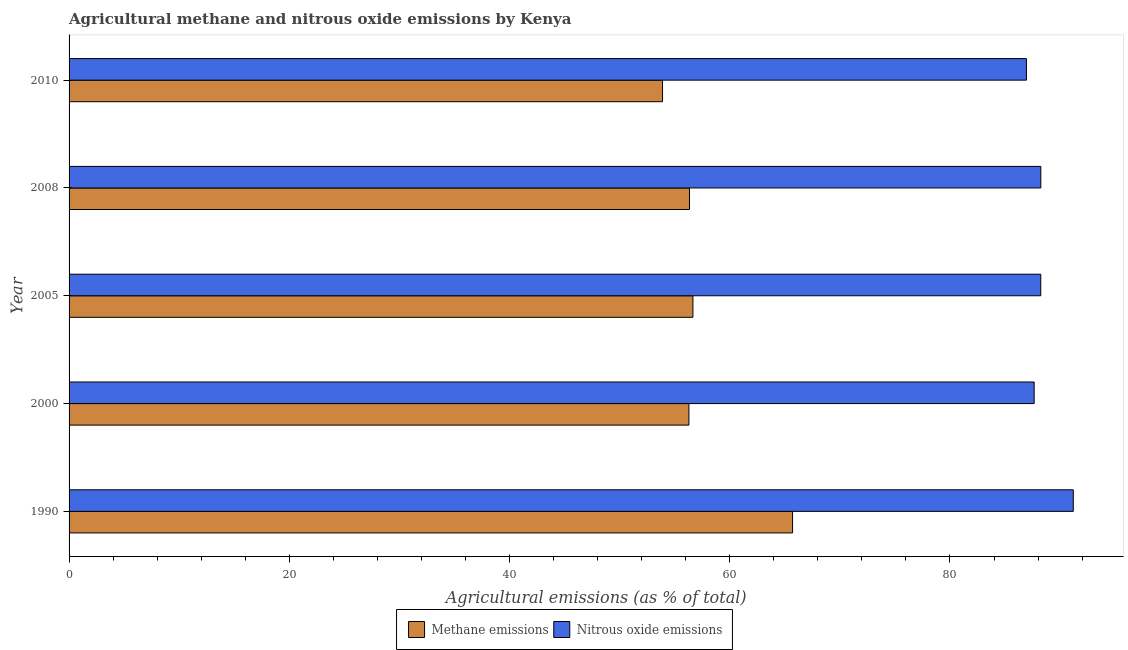How many different coloured bars are there?
Provide a succinct answer. 2. How many groups of bars are there?
Offer a terse response. 5. Are the number of bars on each tick of the Y-axis equal?
Offer a terse response. Yes. How many bars are there on the 5th tick from the bottom?
Your answer should be very brief. 2. What is the amount of nitrous oxide emissions in 2005?
Ensure brevity in your answer.  88.25. Across all years, what is the maximum amount of methane emissions?
Your answer should be compact. 65.71. Across all years, what is the minimum amount of methane emissions?
Your response must be concise. 53.9. In which year was the amount of nitrous oxide emissions maximum?
Ensure brevity in your answer.  1990. In which year was the amount of methane emissions minimum?
Your response must be concise. 2010. What is the total amount of nitrous oxide emissions in the graph?
Your answer should be compact. 442.29. What is the difference between the amount of nitrous oxide emissions in 1990 and that in 2005?
Your answer should be very brief. 2.95. What is the difference between the amount of methane emissions in 2005 and the amount of nitrous oxide emissions in 2010?
Offer a terse response. -30.29. What is the average amount of methane emissions per year?
Your response must be concise. 57.78. In the year 2008, what is the difference between the amount of methane emissions and amount of nitrous oxide emissions?
Offer a terse response. -31.91. In how many years, is the amount of methane emissions greater than 40 %?
Your answer should be very brief. 5. What is the ratio of the amount of nitrous oxide emissions in 1990 to that in 2000?
Give a very brief answer. 1.04. Is the difference between the amount of nitrous oxide emissions in 2000 and 2010 greater than the difference between the amount of methane emissions in 2000 and 2010?
Your answer should be compact. No. What is the difference between the highest and the second highest amount of methane emissions?
Provide a short and direct response. 9.05. What is the difference between the highest and the lowest amount of methane emissions?
Provide a succinct answer. 11.81. What does the 2nd bar from the top in 1990 represents?
Your answer should be compact. Methane emissions. What does the 1st bar from the bottom in 2005 represents?
Keep it short and to the point. Methane emissions. Are all the bars in the graph horizontal?
Keep it short and to the point. Yes. How many years are there in the graph?
Your response must be concise. 5. Does the graph contain any zero values?
Provide a short and direct response. No. Does the graph contain grids?
Keep it short and to the point. No. Where does the legend appear in the graph?
Offer a very short reply. Bottom center. How many legend labels are there?
Offer a terse response. 2. What is the title of the graph?
Your answer should be very brief. Agricultural methane and nitrous oxide emissions by Kenya. What is the label or title of the X-axis?
Your answer should be very brief. Agricultural emissions (as % of total). What is the Agricultural emissions (as % of total) of Methane emissions in 1990?
Give a very brief answer. 65.71. What is the Agricultural emissions (as % of total) of Nitrous oxide emissions in 1990?
Make the answer very short. 91.2. What is the Agricultural emissions (as % of total) of Methane emissions in 2000?
Offer a very short reply. 56.29. What is the Agricultural emissions (as % of total) in Nitrous oxide emissions in 2000?
Your answer should be compact. 87.65. What is the Agricultural emissions (as % of total) in Methane emissions in 2005?
Provide a short and direct response. 56.66. What is the Agricultural emissions (as % of total) in Nitrous oxide emissions in 2005?
Offer a terse response. 88.25. What is the Agricultural emissions (as % of total) of Methane emissions in 2008?
Offer a terse response. 56.35. What is the Agricultural emissions (as % of total) of Nitrous oxide emissions in 2008?
Offer a terse response. 88.25. What is the Agricultural emissions (as % of total) of Methane emissions in 2010?
Make the answer very short. 53.9. What is the Agricultural emissions (as % of total) in Nitrous oxide emissions in 2010?
Ensure brevity in your answer.  86.94. Across all years, what is the maximum Agricultural emissions (as % of total) of Methane emissions?
Keep it short and to the point. 65.71. Across all years, what is the maximum Agricultural emissions (as % of total) in Nitrous oxide emissions?
Keep it short and to the point. 91.2. Across all years, what is the minimum Agricultural emissions (as % of total) of Methane emissions?
Offer a very short reply. 53.9. Across all years, what is the minimum Agricultural emissions (as % of total) in Nitrous oxide emissions?
Give a very brief answer. 86.94. What is the total Agricultural emissions (as % of total) in Methane emissions in the graph?
Ensure brevity in your answer.  288.9. What is the total Agricultural emissions (as % of total) in Nitrous oxide emissions in the graph?
Make the answer very short. 442.29. What is the difference between the Agricultural emissions (as % of total) of Methane emissions in 1990 and that in 2000?
Provide a succinct answer. 9.42. What is the difference between the Agricultural emissions (as % of total) in Nitrous oxide emissions in 1990 and that in 2000?
Give a very brief answer. 3.55. What is the difference between the Agricultural emissions (as % of total) in Methane emissions in 1990 and that in 2005?
Your answer should be compact. 9.05. What is the difference between the Agricultural emissions (as % of total) of Nitrous oxide emissions in 1990 and that in 2005?
Offer a very short reply. 2.95. What is the difference between the Agricultural emissions (as % of total) of Methane emissions in 1990 and that in 2008?
Offer a very short reply. 9.36. What is the difference between the Agricultural emissions (as % of total) in Nitrous oxide emissions in 1990 and that in 2008?
Your response must be concise. 2.95. What is the difference between the Agricultural emissions (as % of total) of Methane emissions in 1990 and that in 2010?
Your answer should be very brief. 11.81. What is the difference between the Agricultural emissions (as % of total) in Nitrous oxide emissions in 1990 and that in 2010?
Provide a short and direct response. 4.26. What is the difference between the Agricultural emissions (as % of total) in Methane emissions in 2000 and that in 2005?
Your response must be concise. -0.37. What is the difference between the Agricultural emissions (as % of total) in Nitrous oxide emissions in 2000 and that in 2005?
Offer a terse response. -0.6. What is the difference between the Agricultural emissions (as % of total) in Methane emissions in 2000 and that in 2008?
Your answer should be very brief. -0.06. What is the difference between the Agricultural emissions (as % of total) of Nitrous oxide emissions in 2000 and that in 2008?
Your response must be concise. -0.61. What is the difference between the Agricultural emissions (as % of total) of Methane emissions in 2000 and that in 2010?
Your answer should be very brief. 2.39. What is the difference between the Agricultural emissions (as % of total) in Nitrous oxide emissions in 2000 and that in 2010?
Keep it short and to the point. 0.7. What is the difference between the Agricultural emissions (as % of total) of Methane emissions in 2005 and that in 2008?
Give a very brief answer. 0.31. What is the difference between the Agricultural emissions (as % of total) in Nitrous oxide emissions in 2005 and that in 2008?
Give a very brief answer. -0. What is the difference between the Agricultural emissions (as % of total) of Methane emissions in 2005 and that in 2010?
Offer a very short reply. 2.76. What is the difference between the Agricultural emissions (as % of total) of Nitrous oxide emissions in 2005 and that in 2010?
Give a very brief answer. 1.3. What is the difference between the Agricultural emissions (as % of total) of Methane emissions in 2008 and that in 2010?
Make the answer very short. 2.45. What is the difference between the Agricultural emissions (as % of total) of Nitrous oxide emissions in 2008 and that in 2010?
Make the answer very short. 1.31. What is the difference between the Agricultural emissions (as % of total) of Methane emissions in 1990 and the Agricultural emissions (as % of total) of Nitrous oxide emissions in 2000?
Offer a terse response. -21.94. What is the difference between the Agricultural emissions (as % of total) of Methane emissions in 1990 and the Agricultural emissions (as % of total) of Nitrous oxide emissions in 2005?
Offer a very short reply. -22.54. What is the difference between the Agricultural emissions (as % of total) in Methane emissions in 1990 and the Agricultural emissions (as % of total) in Nitrous oxide emissions in 2008?
Provide a succinct answer. -22.54. What is the difference between the Agricultural emissions (as % of total) of Methane emissions in 1990 and the Agricultural emissions (as % of total) of Nitrous oxide emissions in 2010?
Offer a very short reply. -21.24. What is the difference between the Agricultural emissions (as % of total) of Methane emissions in 2000 and the Agricultural emissions (as % of total) of Nitrous oxide emissions in 2005?
Your response must be concise. -31.96. What is the difference between the Agricultural emissions (as % of total) in Methane emissions in 2000 and the Agricultural emissions (as % of total) in Nitrous oxide emissions in 2008?
Your answer should be compact. -31.96. What is the difference between the Agricultural emissions (as % of total) of Methane emissions in 2000 and the Agricultural emissions (as % of total) of Nitrous oxide emissions in 2010?
Keep it short and to the point. -30.65. What is the difference between the Agricultural emissions (as % of total) in Methane emissions in 2005 and the Agricultural emissions (as % of total) in Nitrous oxide emissions in 2008?
Ensure brevity in your answer.  -31.59. What is the difference between the Agricultural emissions (as % of total) of Methane emissions in 2005 and the Agricultural emissions (as % of total) of Nitrous oxide emissions in 2010?
Give a very brief answer. -30.29. What is the difference between the Agricultural emissions (as % of total) of Methane emissions in 2008 and the Agricultural emissions (as % of total) of Nitrous oxide emissions in 2010?
Your answer should be compact. -30.6. What is the average Agricultural emissions (as % of total) in Methane emissions per year?
Your response must be concise. 57.78. What is the average Agricultural emissions (as % of total) of Nitrous oxide emissions per year?
Make the answer very short. 88.46. In the year 1990, what is the difference between the Agricultural emissions (as % of total) in Methane emissions and Agricultural emissions (as % of total) in Nitrous oxide emissions?
Give a very brief answer. -25.49. In the year 2000, what is the difference between the Agricultural emissions (as % of total) of Methane emissions and Agricultural emissions (as % of total) of Nitrous oxide emissions?
Provide a succinct answer. -31.36. In the year 2005, what is the difference between the Agricultural emissions (as % of total) in Methane emissions and Agricultural emissions (as % of total) in Nitrous oxide emissions?
Offer a very short reply. -31.59. In the year 2008, what is the difference between the Agricultural emissions (as % of total) of Methane emissions and Agricultural emissions (as % of total) of Nitrous oxide emissions?
Offer a very short reply. -31.9. In the year 2010, what is the difference between the Agricultural emissions (as % of total) in Methane emissions and Agricultural emissions (as % of total) in Nitrous oxide emissions?
Make the answer very short. -33.05. What is the ratio of the Agricultural emissions (as % of total) of Methane emissions in 1990 to that in 2000?
Ensure brevity in your answer.  1.17. What is the ratio of the Agricultural emissions (as % of total) in Nitrous oxide emissions in 1990 to that in 2000?
Your answer should be compact. 1.04. What is the ratio of the Agricultural emissions (as % of total) of Methane emissions in 1990 to that in 2005?
Keep it short and to the point. 1.16. What is the ratio of the Agricultural emissions (as % of total) of Nitrous oxide emissions in 1990 to that in 2005?
Ensure brevity in your answer.  1.03. What is the ratio of the Agricultural emissions (as % of total) of Methane emissions in 1990 to that in 2008?
Ensure brevity in your answer.  1.17. What is the ratio of the Agricultural emissions (as % of total) in Nitrous oxide emissions in 1990 to that in 2008?
Ensure brevity in your answer.  1.03. What is the ratio of the Agricultural emissions (as % of total) of Methane emissions in 1990 to that in 2010?
Your answer should be very brief. 1.22. What is the ratio of the Agricultural emissions (as % of total) in Nitrous oxide emissions in 1990 to that in 2010?
Provide a succinct answer. 1.05. What is the ratio of the Agricultural emissions (as % of total) of Nitrous oxide emissions in 2000 to that in 2005?
Provide a short and direct response. 0.99. What is the ratio of the Agricultural emissions (as % of total) in Methane emissions in 2000 to that in 2010?
Make the answer very short. 1.04. What is the ratio of the Agricultural emissions (as % of total) of Nitrous oxide emissions in 2005 to that in 2008?
Provide a short and direct response. 1. What is the ratio of the Agricultural emissions (as % of total) in Methane emissions in 2005 to that in 2010?
Your answer should be compact. 1.05. What is the ratio of the Agricultural emissions (as % of total) of Nitrous oxide emissions in 2005 to that in 2010?
Your answer should be very brief. 1.01. What is the ratio of the Agricultural emissions (as % of total) in Methane emissions in 2008 to that in 2010?
Provide a short and direct response. 1.05. What is the difference between the highest and the second highest Agricultural emissions (as % of total) in Methane emissions?
Keep it short and to the point. 9.05. What is the difference between the highest and the second highest Agricultural emissions (as % of total) in Nitrous oxide emissions?
Offer a very short reply. 2.95. What is the difference between the highest and the lowest Agricultural emissions (as % of total) of Methane emissions?
Offer a very short reply. 11.81. What is the difference between the highest and the lowest Agricultural emissions (as % of total) of Nitrous oxide emissions?
Provide a short and direct response. 4.26. 